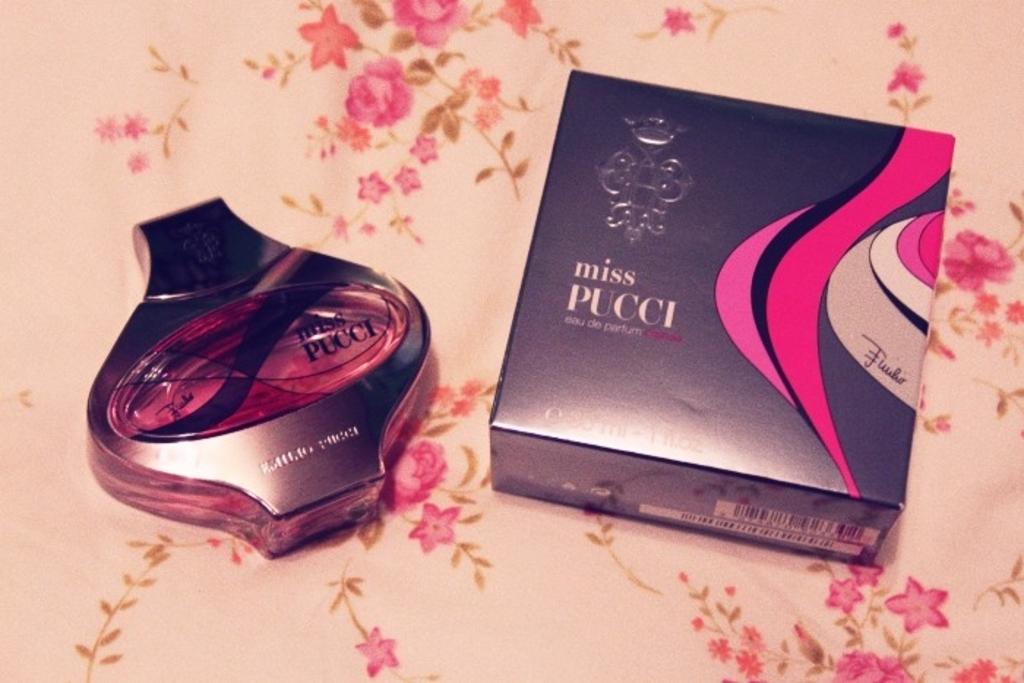What is this perfume called?
Your answer should be very brief. Miss pucci. 